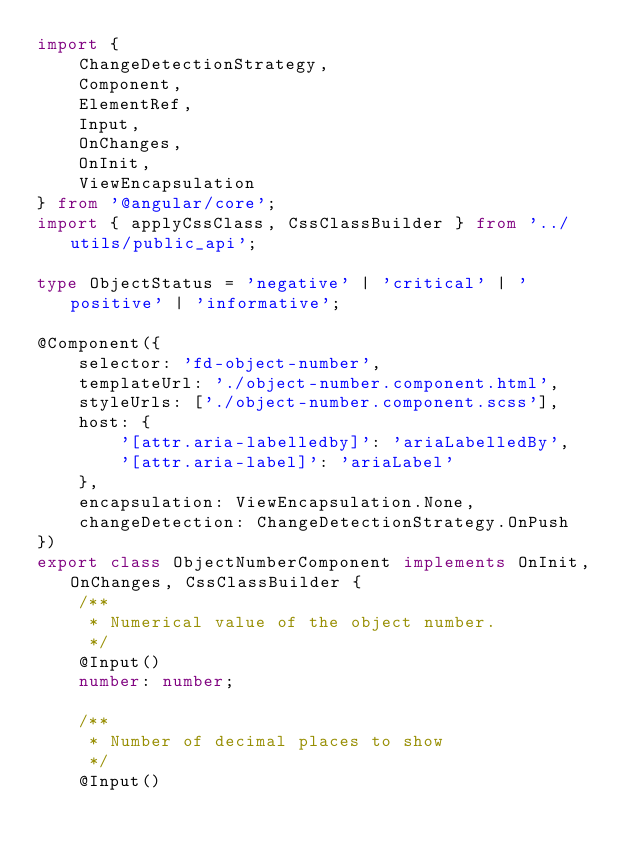Convert code to text. <code><loc_0><loc_0><loc_500><loc_500><_TypeScript_>import {
    ChangeDetectionStrategy,
    Component,
    ElementRef,
    Input,
    OnChanges,
    OnInit,
    ViewEncapsulation
} from '@angular/core';
import { applyCssClass, CssClassBuilder } from '../utils/public_api';

type ObjectStatus = 'negative' | 'critical' | 'positive' | 'informative';

@Component({
    selector: 'fd-object-number',
    templateUrl: './object-number.component.html',
    styleUrls: ['./object-number.component.scss'],
    host: {
        '[attr.aria-labelledby]': 'ariaLabelledBy',
        '[attr.aria-label]': 'ariaLabel'
    },
    encapsulation: ViewEncapsulation.None,
    changeDetection: ChangeDetectionStrategy.OnPush
})
export class ObjectNumberComponent implements OnInit, OnChanges, CssClassBuilder {
    /**
     * Numerical value of the object number.
     */
    @Input()
    number: number;

    /**
     * Number of decimal places to show
     */
    @Input()</code> 